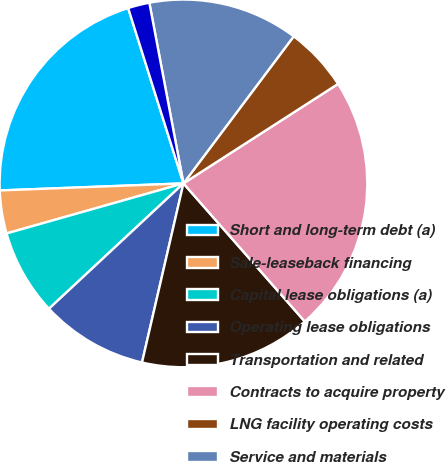Convert chart to OTSL. <chart><loc_0><loc_0><loc_500><loc_500><pie_chart><fcel>Short and long-term debt (a)<fcel>Sale-leaseback financing<fcel>Capital lease obligations (a)<fcel>Operating lease obligations<fcel>Transportation and related<fcel>Contracts to acquire property<fcel>LNG facility operating costs<fcel>Service and materials<fcel>Unconditional purchase<nl><fcel>20.75%<fcel>3.78%<fcel>7.55%<fcel>9.44%<fcel>15.09%<fcel>22.63%<fcel>5.66%<fcel>13.21%<fcel>1.89%<nl></chart> 